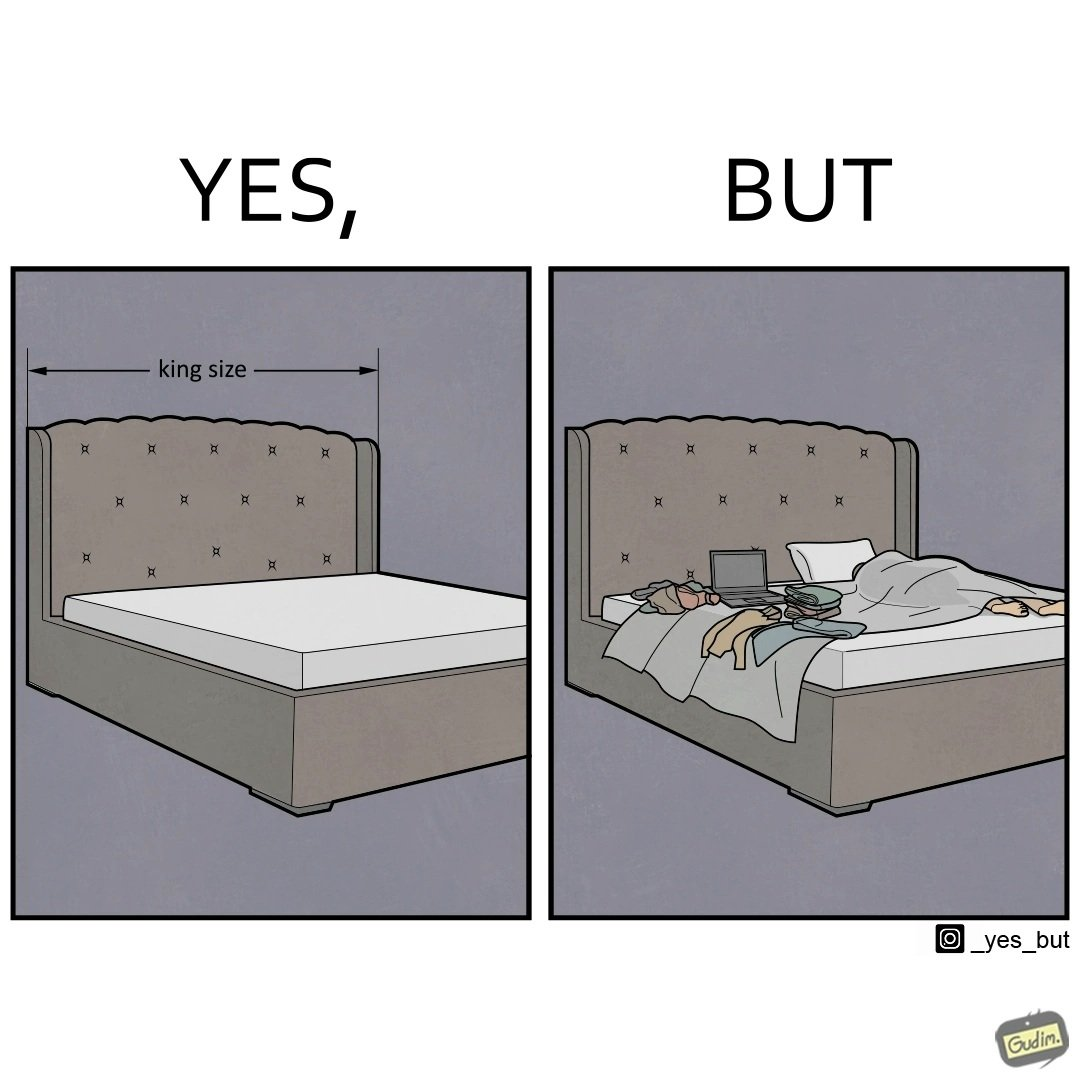Describe the satirical element in this image. Although the person has purchased a king size bed, but only less than half of the space is used by the person for sleeping. 